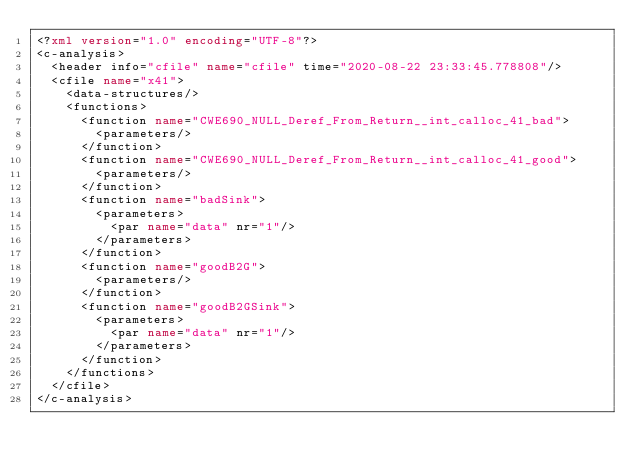<code> <loc_0><loc_0><loc_500><loc_500><_XML_><?xml version="1.0" encoding="UTF-8"?>
<c-analysis>
  <header info="cfile" name="cfile" time="2020-08-22 23:33:45.778808"/>
  <cfile name="x41">
    <data-structures/>
    <functions>
      <function name="CWE690_NULL_Deref_From_Return__int_calloc_41_bad">
        <parameters/>
      </function>
      <function name="CWE690_NULL_Deref_From_Return__int_calloc_41_good">
        <parameters/>
      </function>
      <function name="badSink">
        <parameters>
          <par name="data" nr="1"/>
        </parameters>
      </function>
      <function name="goodB2G">
        <parameters/>
      </function>
      <function name="goodB2GSink">
        <parameters>
          <par name="data" nr="1"/>
        </parameters>
      </function>
    </functions>
  </cfile>
</c-analysis>
</code> 